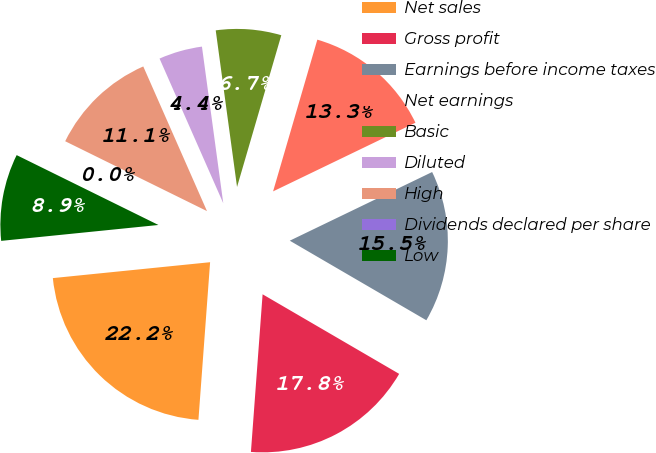Convert chart to OTSL. <chart><loc_0><loc_0><loc_500><loc_500><pie_chart><fcel>Net sales<fcel>Gross profit<fcel>Earnings before income taxes<fcel>Net earnings<fcel>Basic<fcel>Diluted<fcel>High<fcel>Dividends declared per share<fcel>Low<nl><fcel>22.22%<fcel>17.78%<fcel>15.55%<fcel>13.33%<fcel>6.67%<fcel>4.45%<fcel>11.11%<fcel>0.0%<fcel>8.89%<nl></chart> 